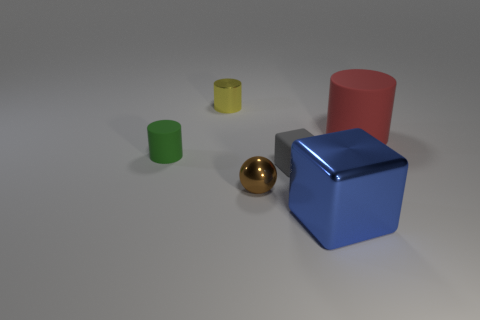Subtract all shiny cylinders. How many cylinders are left? 2 Add 1 yellow shiny cylinders. How many objects exist? 7 Subtract 1 balls. How many balls are left? 0 Subtract all spheres. How many objects are left? 5 Subtract all yellow cylinders. How many cylinders are left? 2 Subtract 1 gray cubes. How many objects are left? 5 Subtract all brown cylinders. Subtract all yellow blocks. How many cylinders are left? 3 Subtract all large metallic things. Subtract all tiny yellow metallic things. How many objects are left? 4 Add 2 yellow objects. How many yellow objects are left? 3 Add 6 yellow objects. How many yellow objects exist? 7 